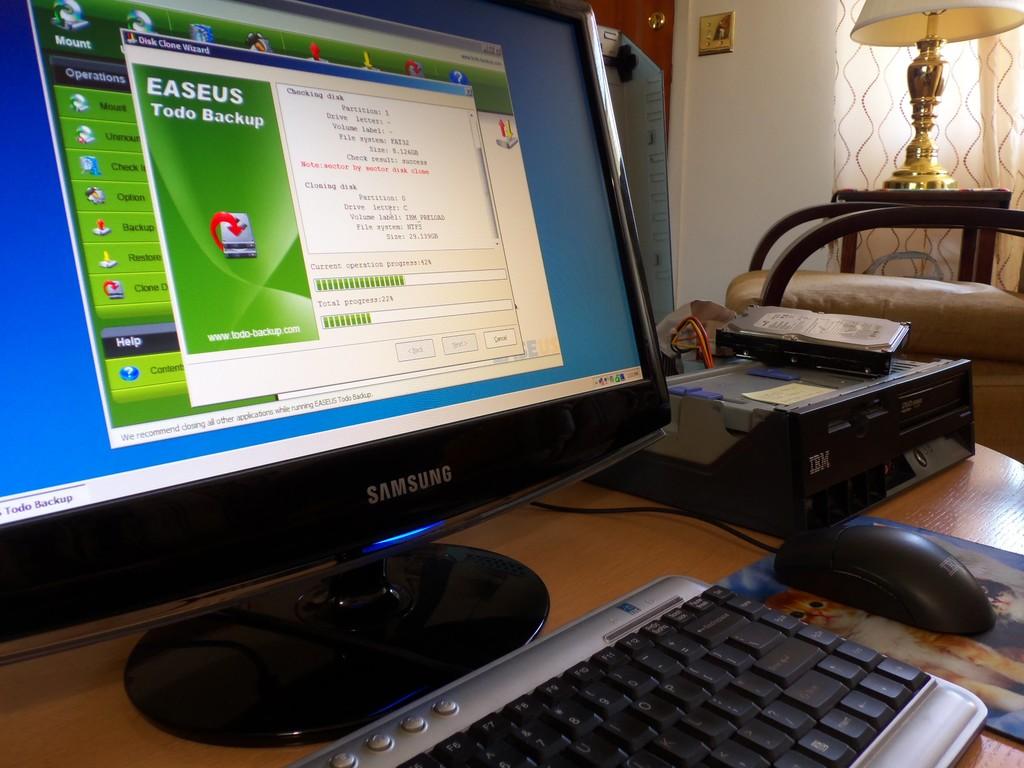Who manufactured the computer?
Your answer should be very brief. Samsung. What is the brand of the computer monitor?
Make the answer very short. Samsung. 